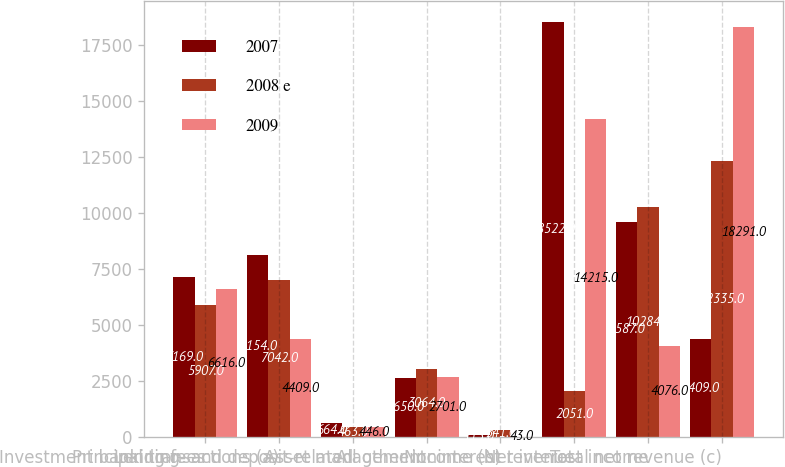Convert chart to OTSL. <chart><loc_0><loc_0><loc_500><loc_500><stacked_bar_chart><ecel><fcel>Investment banking fees<fcel>Principal transactions (a)<fcel>Lending- and deposit-related<fcel>Asset management<fcel>All other income (b)<fcel>Noninterest revenue<fcel>Net interest income<fcel>Total net revenue (c)<nl><fcel>2007<fcel>7169<fcel>8154<fcel>664<fcel>2650<fcel>115<fcel>18522<fcel>9587<fcel>4409<nl><fcel>2008 e<fcel>5907<fcel>7042<fcel>463<fcel>3064<fcel>341<fcel>2051<fcel>10284<fcel>12335<nl><fcel>2009<fcel>6616<fcel>4409<fcel>446<fcel>2701<fcel>43<fcel>14215<fcel>4076<fcel>18291<nl></chart> 